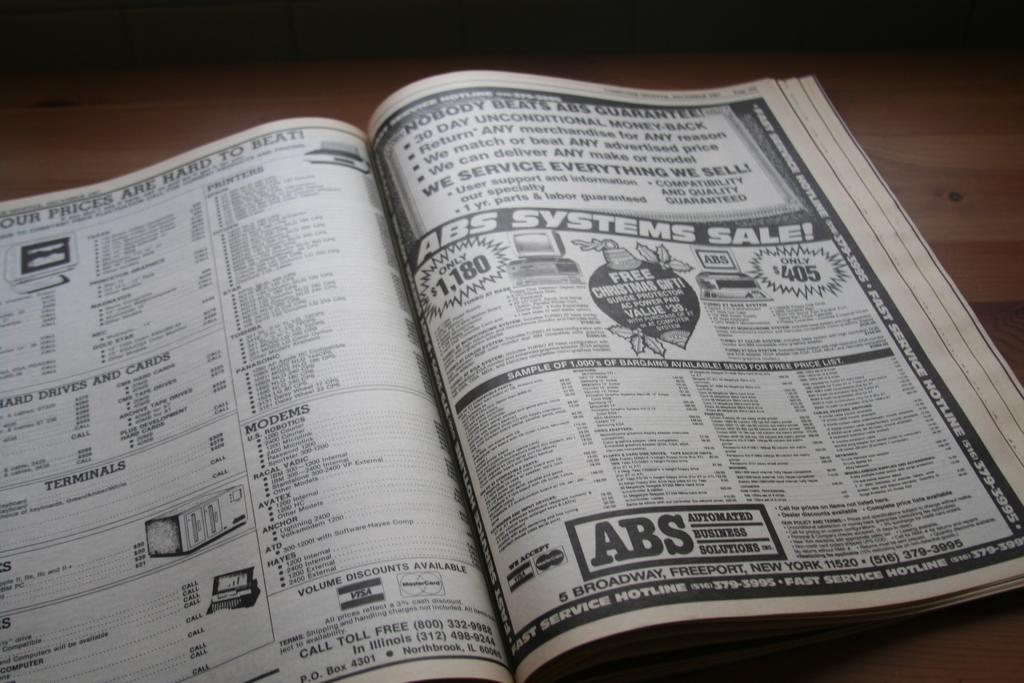What kind of systems sale is being advertised on the right page?
Your answer should be very brief. Abs. What does abs service?
Your answer should be compact. Businesses. 